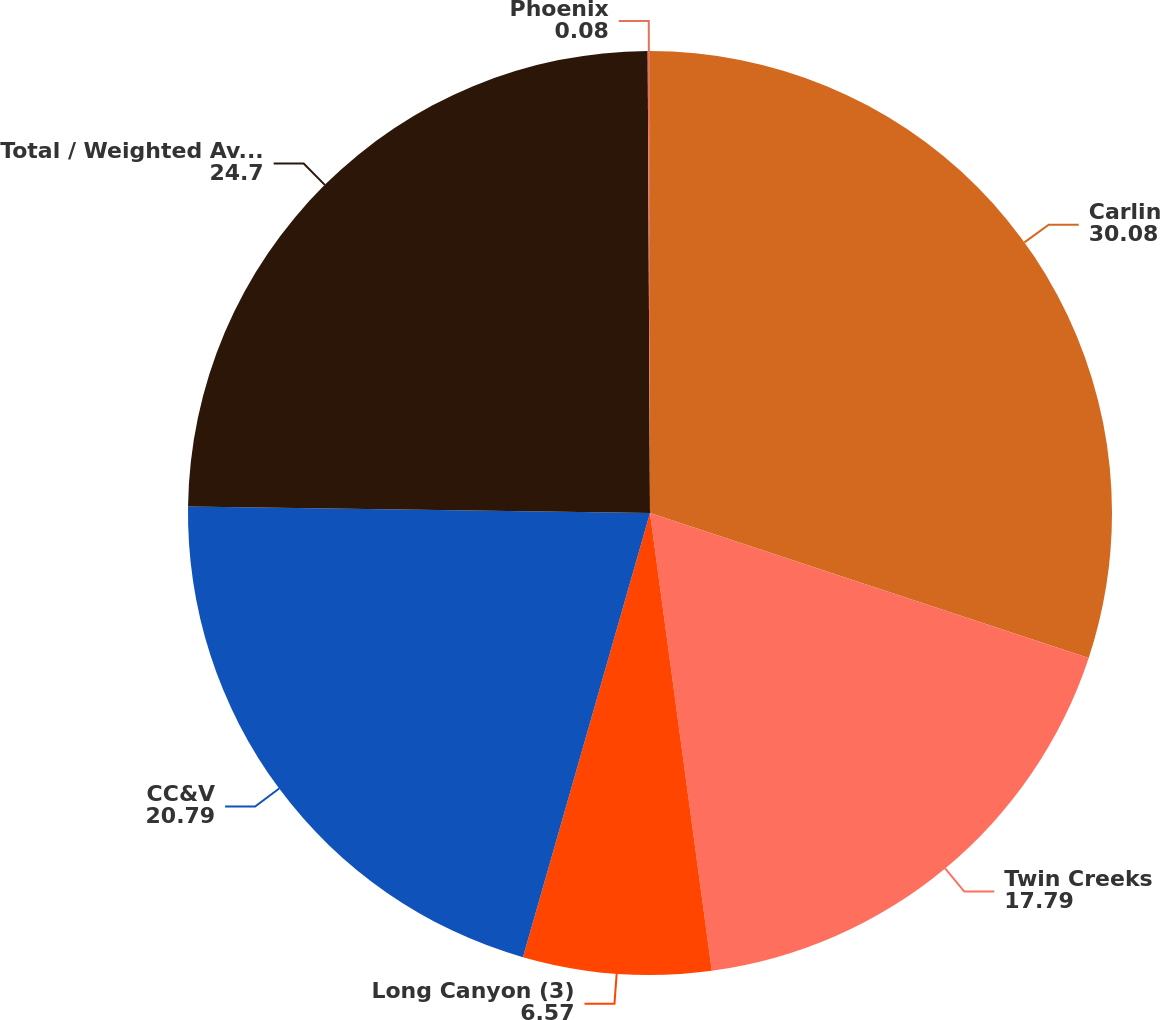Convert chart to OTSL. <chart><loc_0><loc_0><loc_500><loc_500><pie_chart><fcel>Carlin<fcel>Twin Creeks<fcel>Long Canyon (3)<fcel>CC&V<fcel>Total / Weighted Average (4)<fcel>Phoenix<nl><fcel>30.08%<fcel>17.79%<fcel>6.57%<fcel>20.79%<fcel>24.7%<fcel>0.08%<nl></chart> 